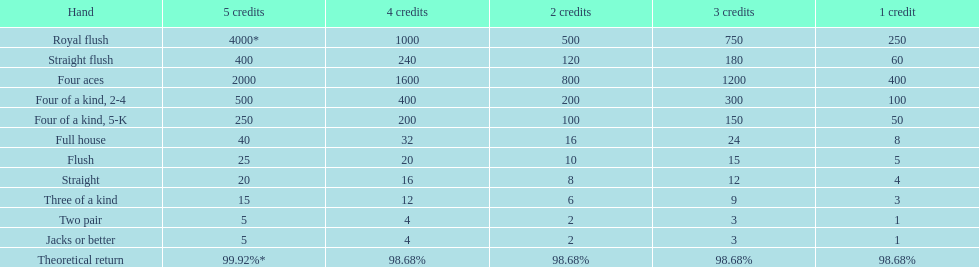How many single-credit flush victories are equivalent to one flush victory worth five credits? 5. Can you parse all the data within this table? {'header': ['Hand', '5 credits', '4 credits', '2 credits', '3 credits', '1 credit'], 'rows': [['Royal flush', '4000*', '1000', '500', '750', '250'], ['Straight flush', '400', '240', '120', '180', '60'], ['Four aces', '2000', '1600', '800', '1200', '400'], ['Four of a kind, 2-4', '500', '400', '200', '300', '100'], ['Four of a kind, 5-K', '250', '200', '100', '150', '50'], ['Full house', '40', '32', '16', '24', '8'], ['Flush', '25', '20', '10', '15', '5'], ['Straight', '20', '16', '8', '12', '4'], ['Three of a kind', '15', '12', '6', '9', '3'], ['Two pair', '5', '4', '2', '3', '1'], ['Jacks or better', '5', '4', '2', '3', '1'], ['Theoretical return', '99.92%*', '98.68%', '98.68%', '98.68%', '98.68%']]} 